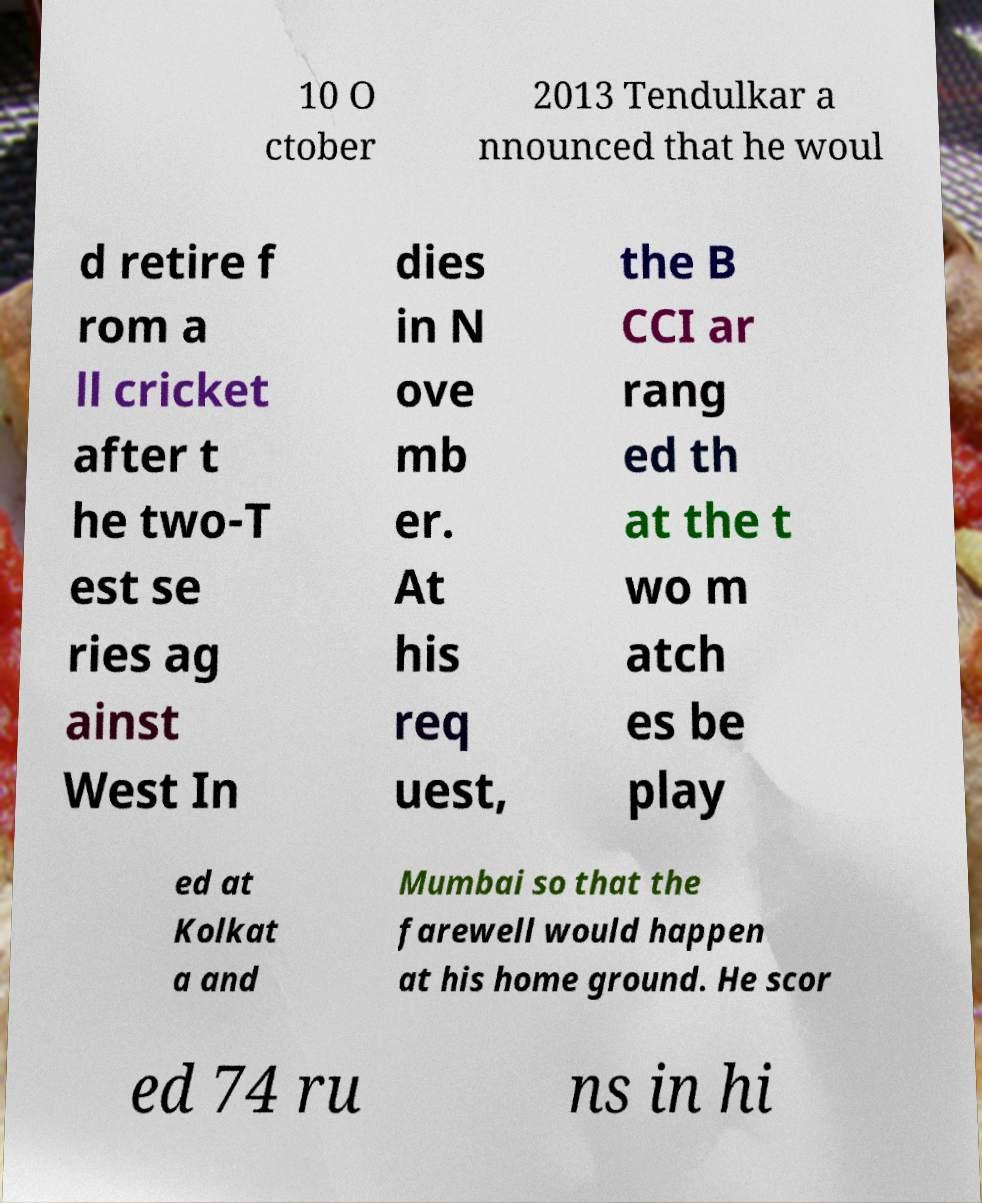There's text embedded in this image that I need extracted. Can you transcribe it verbatim? 10 O ctober 2013 Tendulkar a nnounced that he woul d retire f rom a ll cricket after t he two-T est se ries ag ainst West In dies in N ove mb er. At his req uest, the B CCI ar rang ed th at the t wo m atch es be play ed at Kolkat a and Mumbai so that the farewell would happen at his home ground. He scor ed 74 ru ns in hi 